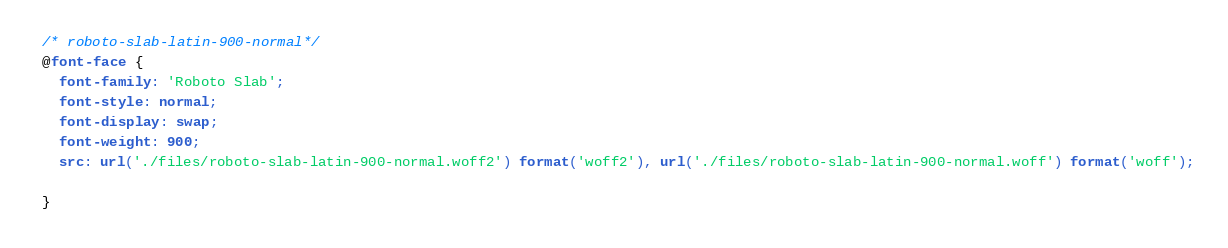<code> <loc_0><loc_0><loc_500><loc_500><_CSS_>/* roboto-slab-latin-900-normal*/
@font-face {
  font-family: 'Roboto Slab';
  font-style: normal;
  font-display: swap;
  font-weight: 900;
  src: url('./files/roboto-slab-latin-900-normal.woff2') format('woff2'), url('./files/roboto-slab-latin-900-normal.woff') format('woff');
  
}
</code> 